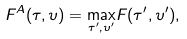<formula> <loc_0><loc_0><loc_500><loc_500>F ^ { A } ( \tau , \upsilon ) = \underset { \tau ^ { \prime } , \upsilon ^ { \prime } } { \max } F ( \tau ^ { \prime } , \upsilon ^ { \prime } ) ,</formula> 